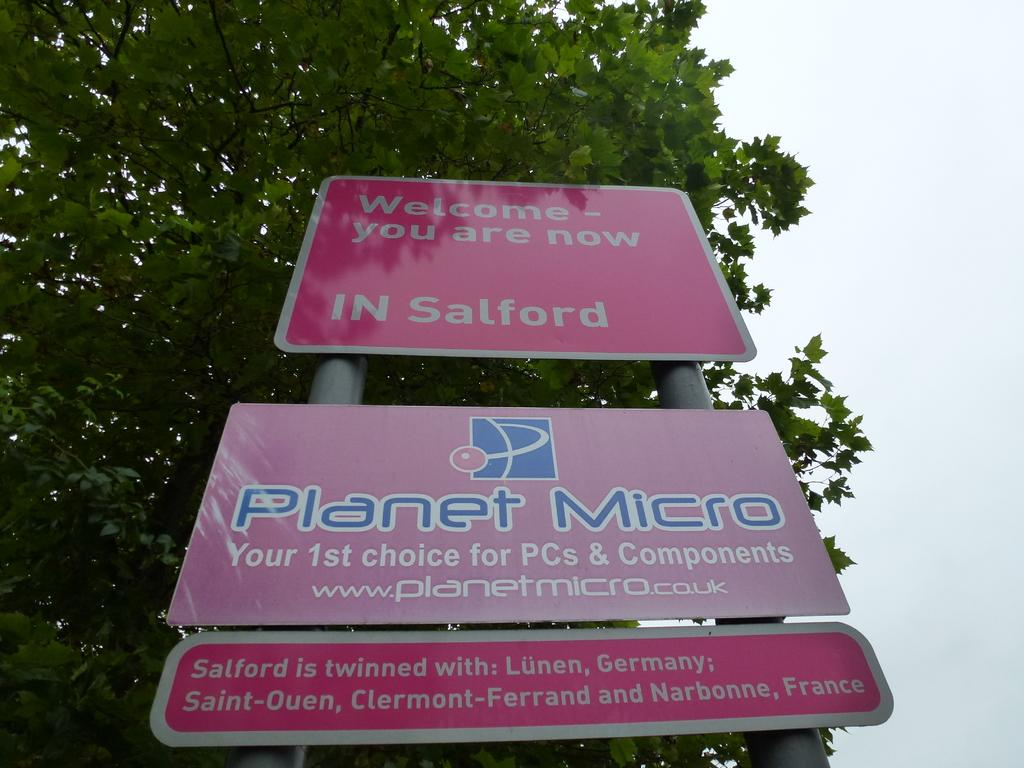What objects are present in the image that are typically used for construction or support? There are boards and poles present in the image. What type of natural element can be seen in the background of the image? There is a tree visible in the background of the image. What is visible in the sky in the background of the image? The sky is visible in the background of the image. How does the payment for the construction work in the image? There is no indication of payment or construction work in the image; it only features boards, poles, a tree, and the sky. What type of cracker is being used to support the poles in the image? There is no cracker present in the image; it only features boards, poles, a tree, and the sky. 